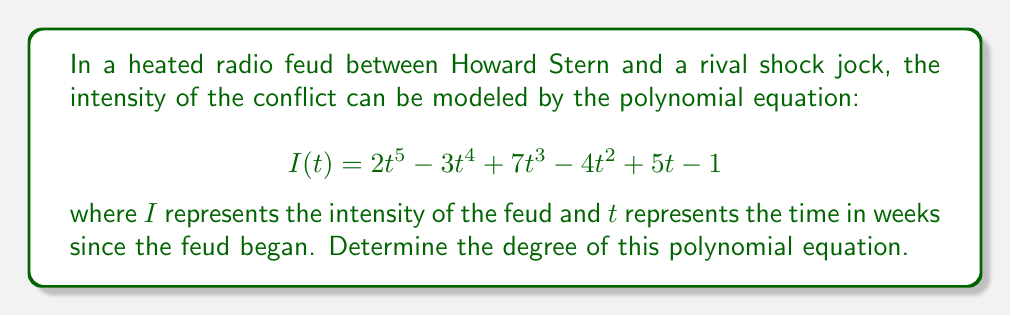Can you answer this question? To determine the degree of a polynomial equation, we need to identify the highest power of the variable in the equation. Let's break this down step-by-step:

1. Examine each term in the polynomial:
   - $2t^5$: The exponent of $t$ is 5
   - $-3t^4$: The exponent of $t$ is 4
   - $7t^3$: The exponent of $t$ is 3
   - $-4t^2$: The exponent of $t$ is 2
   - $5t$: The exponent of $t$ is 1 (often omitted in writing)
   - $-1$: This is a constant term, so the exponent of $t$ is 0

2. Identify the highest exponent:
   The highest exponent of $t$ in this polynomial is 5, which appears in the term $2t^5$.

3. Conclusion:
   The degree of a polynomial is defined as the highest power of the variable in the polynomial. In this case, the highest power of $t$ is 5.

Therefore, the degree of the polynomial equation modeling the intensity of the radio feud is 5.
Answer: 5 